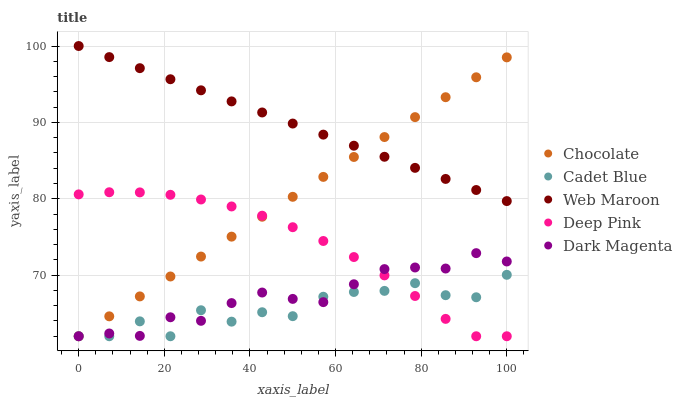Does Cadet Blue have the minimum area under the curve?
Answer yes or no. Yes. Does Web Maroon have the maximum area under the curve?
Answer yes or no. Yes. Does Dark Magenta have the minimum area under the curve?
Answer yes or no. No. Does Dark Magenta have the maximum area under the curve?
Answer yes or no. No. Is Web Maroon the smoothest?
Answer yes or no. Yes. Is Cadet Blue the roughest?
Answer yes or no. Yes. Is Dark Magenta the smoothest?
Answer yes or no. No. Is Dark Magenta the roughest?
Answer yes or no. No. Does Cadet Blue have the lowest value?
Answer yes or no. Yes. Does Web Maroon have the lowest value?
Answer yes or no. No. Does Web Maroon have the highest value?
Answer yes or no. Yes. Does Dark Magenta have the highest value?
Answer yes or no. No. Is Cadet Blue less than Web Maroon?
Answer yes or no. Yes. Is Web Maroon greater than Deep Pink?
Answer yes or no. Yes. Does Deep Pink intersect Dark Magenta?
Answer yes or no. Yes. Is Deep Pink less than Dark Magenta?
Answer yes or no. No. Is Deep Pink greater than Dark Magenta?
Answer yes or no. No. Does Cadet Blue intersect Web Maroon?
Answer yes or no. No. 